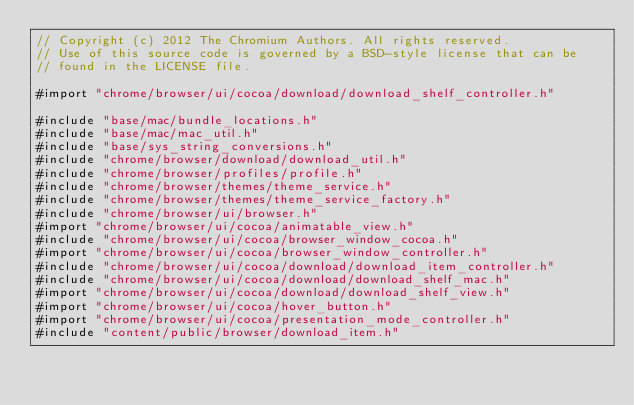<code> <loc_0><loc_0><loc_500><loc_500><_ObjectiveC_>// Copyright (c) 2012 The Chromium Authors. All rights reserved.
// Use of this source code is governed by a BSD-style license that can be
// found in the LICENSE file.

#import "chrome/browser/ui/cocoa/download/download_shelf_controller.h"

#include "base/mac/bundle_locations.h"
#include "base/mac/mac_util.h"
#include "base/sys_string_conversions.h"
#include "chrome/browser/download/download_util.h"
#include "chrome/browser/profiles/profile.h"
#include "chrome/browser/themes/theme_service.h"
#include "chrome/browser/themes/theme_service_factory.h"
#include "chrome/browser/ui/browser.h"
#import "chrome/browser/ui/cocoa/animatable_view.h"
#include "chrome/browser/ui/cocoa/browser_window_cocoa.h"
#import "chrome/browser/ui/cocoa/browser_window_controller.h"
#include "chrome/browser/ui/cocoa/download/download_item_controller.h"
#include "chrome/browser/ui/cocoa/download/download_shelf_mac.h"
#import "chrome/browser/ui/cocoa/download/download_shelf_view.h"
#import "chrome/browser/ui/cocoa/hover_button.h"
#import "chrome/browser/ui/cocoa/presentation_mode_controller.h"
#include "content/public/browser/download_item.h"</code> 